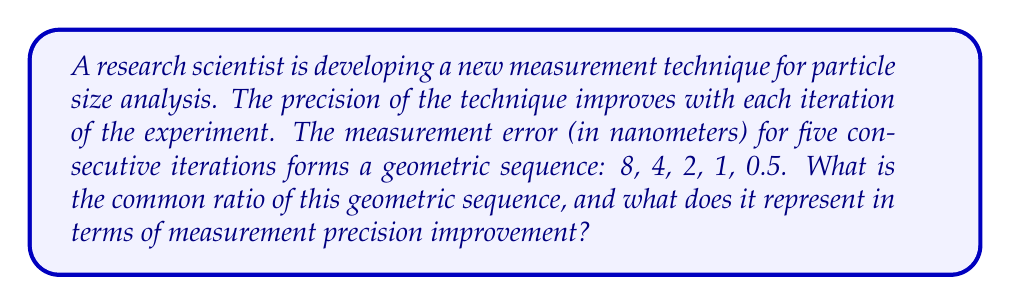Can you answer this question? To solve this problem, we need to follow these steps:

1. Identify the geometric sequence:
   $a_1 = 8$, $a_2 = 4$, $a_3 = 2$, $a_4 = 1$, $a_5 = 0.5$

2. Recall that in a geometric sequence, each term is a constant multiple of the previous term. This constant is called the common ratio, denoted as $r$.

3. Calculate the common ratio by dividing any term by the previous term:
   $r = \frac{a_2}{a_1} = \frac{a_3}{a_2} = \frac{a_4}{a_3} = \frac{a_5}{a_4}$

4. Let's calculate using the first two terms:
   $r = \frac{a_2}{a_1} = \frac{4}{8} = \frac{1}{2} = 0.5$

5. Verify this ratio for other consecutive terms:
   $\frac{2}{4} = \frac{1}{2}$, $\frac{1}{2} = \frac{1}{2}$, $\frac{0.5}{1} = \frac{1}{2}$

6. Interpret the meaning of the common ratio:
   A common ratio of 0.5 means that each subsequent measurement error is half of the previous one. This represents a 50% reduction in measurement error with each iteration, or a doubling of precision.
Answer: $r = 0.5$, representing a 50% reduction in measurement error per iteration. 